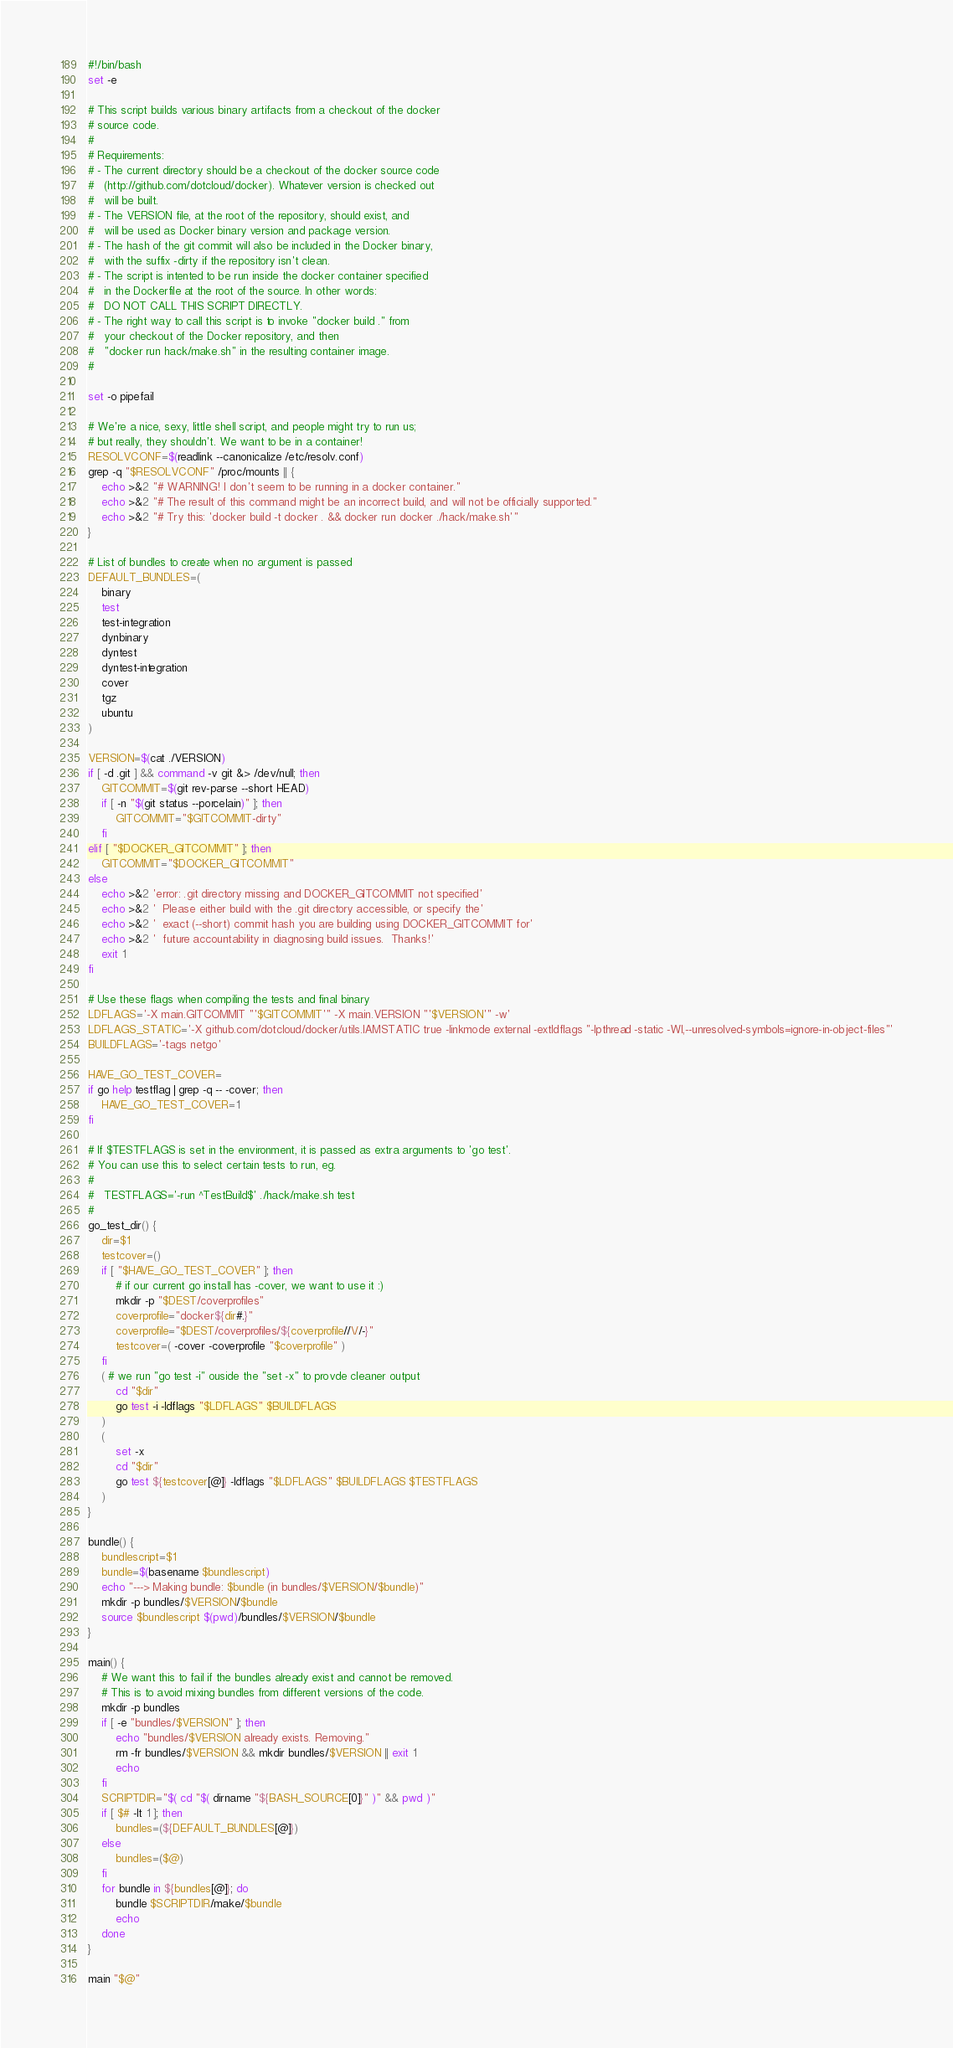<code> <loc_0><loc_0><loc_500><loc_500><_Bash_>#!/bin/bash
set -e

# This script builds various binary artifacts from a checkout of the docker
# source code.
#
# Requirements:
# - The current directory should be a checkout of the docker source code
#   (http://github.com/dotcloud/docker). Whatever version is checked out
#   will be built.
# - The VERSION file, at the root of the repository, should exist, and
#   will be used as Docker binary version and package version.
# - The hash of the git commit will also be included in the Docker binary,
#   with the suffix -dirty if the repository isn't clean.
# - The script is intented to be run inside the docker container specified
#   in the Dockerfile at the root of the source. In other words:
#   DO NOT CALL THIS SCRIPT DIRECTLY.
# - The right way to call this script is to invoke "docker build ." from
#   your checkout of the Docker repository, and then
#   "docker run hack/make.sh" in the resulting container image.
#

set -o pipefail

# We're a nice, sexy, little shell script, and people might try to run us;
# but really, they shouldn't. We want to be in a container!
RESOLVCONF=$(readlink --canonicalize /etc/resolv.conf)
grep -q "$RESOLVCONF" /proc/mounts || {
	echo >&2 "# WARNING! I don't seem to be running in a docker container."
	echo >&2 "# The result of this command might be an incorrect build, and will not be officially supported."
	echo >&2 "# Try this: 'docker build -t docker . && docker run docker ./hack/make.sh'"
}

# List of bundles to create when no argument is passed
DEFAULT_BUNDLES=(
	binary
	test
	test-integration
	dynbinary
	dyntest
	dyntest-integration
	cover
	tgz
	ubuntu
)

VERSION=$(cat ./VERSION)
if [ -d .git ] && command -v git &> /dev/null; then
	GITCOMMIT=$(git rev-parse --short HEAD)
	if [ -n "$(git status --porcelain)" ]; then
		GITCOMMIT="$GITCOMMIT-dirty"
	fi
elif [ "$DOCKER_GITCOMMIT" ]; then
	GITCOMMIT="$DOCKER_GITCOMMIT"
else
	echo >&2 'error: .git directory missing and DOCKER_GITCOMMIT not specified'
	echo >&2 '  Please either build with the .git directory accessible, or specify the'
	echo >&2 '  exact (--short) commit hash you are building using DOCKER_GITCOMMIT for'
	echo >&2 '  future accountability in diagnosing build issues.  Thanks!'
	exit 1
fi

# Use these flags when compiling the tests and final binary
LDFLAGS='-X main.GITCOMMIT "'$GITCOMMIT'" -X main.VERSION "'$VERSION'" -w'
LDFLAGS_STATIC='-X github.com/dotcloud/docker/utils.IAMSTATIC true -linkmode external -extldflags "-lpthread -static -Wl,--unresolved-symbols=ignore-in-object-files"'
BUILDFLAGS='-tags netgo'

HAVE_GO_TEST_COVER=
if go help testflag | grep -q -- -cover; then
	HAVE_GO_TEST_COVER=1
fi

# If $TESTFLAGS is set in the environment, it is passed as extra arguments to 'go test'.
# You can use this to select certain tests to run, eg.
#
#   TESTFLAGS='-run ^TestBuild$' ./hack/make.sh test
#
go_test_dir() {
	dir=$1
	testcover=()
	if [ "$HAVE_GO_TEST_COVER" ]; then
		# if our current go install has -cover, we want to use it :)
		mkdir -p "$DEST/coverprofiles"
		coverprofile="docker${dir#.}"
		coverprofile="$DEST/coverprofiles/${coverprofile//\//-}"
		testcover=( -cover -coverprofile "$coverprofile" )
	fi
	( # we run "go test -i" ouside the "set -x" to provde cleaner output
		cd "$dir"
		go test -i -ldflags "$LDFLAGS" $BUILDFLAGS
	)
	(
		set -x
		cd "$dir"
		go test ${testcover[@]} -ldflags "$LDFLAGS" $BUILDFLAGS $TESTFLAGS
	)
}

bundle() {
	bundlescript=$1
	bundle=$(basename $bundlescript)
	echo "---> Making bundle: $bundle (in bundles/$VERSION/$bundle)"
	mkdir -p bundles/$VERSION/$bundle
	source $bundlescript $(pwd)/bundles/$VERSION/$bundle
}

main() {
	# We want this to fail if the bundles already exist and cannot be removed.
	# This is to avoid mixing bundles from different versions of the code.
	mkdir -p bundles
	if [ -e "bundles/$VERSION" ]; then
		echo "bundles/$VERSION already exists. Removing."
		rm -fr bundles/$VERSION && mkdir bundles/$VERSION || exit 1
		echo
	fi
	SCRIPTDIR="$( cd "$( dirname "${BASH_SOURCE[0]}" )" && pwd )"
	if [ $# -lt 1 ]; then
		bundles=(${DEFAULT_BUNDLES[@]})
	else
		bundles=($@)
	fi
	for bundle in ${bundles[@]}; do
		bundle $SCRIPTDIR/make/$bundle
		echo
	done
}

main "$@"
</code> 